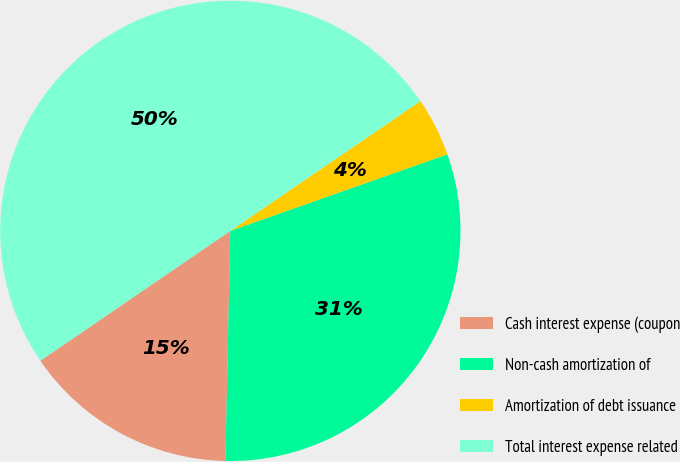Convert chart. <chart><loc_0><loc_0><loc_500><loc_500><pie_chart><fcel>Cash interest expense (coupon<fcel>Non-cash amortization of<fcel>Amortization of debt issuance<fcel>Total interest expense related<nl><fcel>15.12%<fcel>30.74%<fcel>4.14%<fcel>50.0%<nl></chart> 